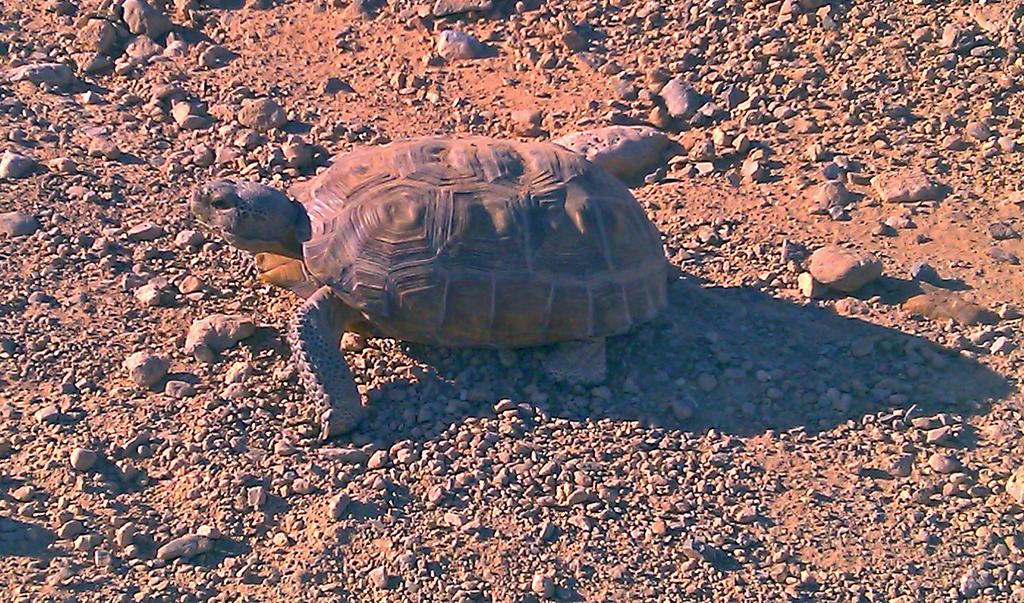What type of animal is on the ground in the image? There is a tortoise on the ground in the image. What else can be seen in the image besides the tortoise? There are stones visible in the image. What reward does the frog receive for completing the task in the image? There is no frog present in the image, and therefore no task or reward can be observed. 